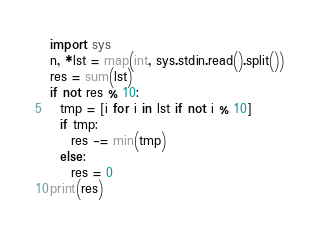<code> <loc_0><loc_0><loc_500><loc_500><_Python_>import sys
n, *lst = map(int, sys.stdin.read().split())
res = sum(lst)
if not res % 10:
  tmp = [i for i in lst if not i % 10]
  if tmp:
    res -= min(tmp)
  else:
    res = 0
print(res)
  
</code> 